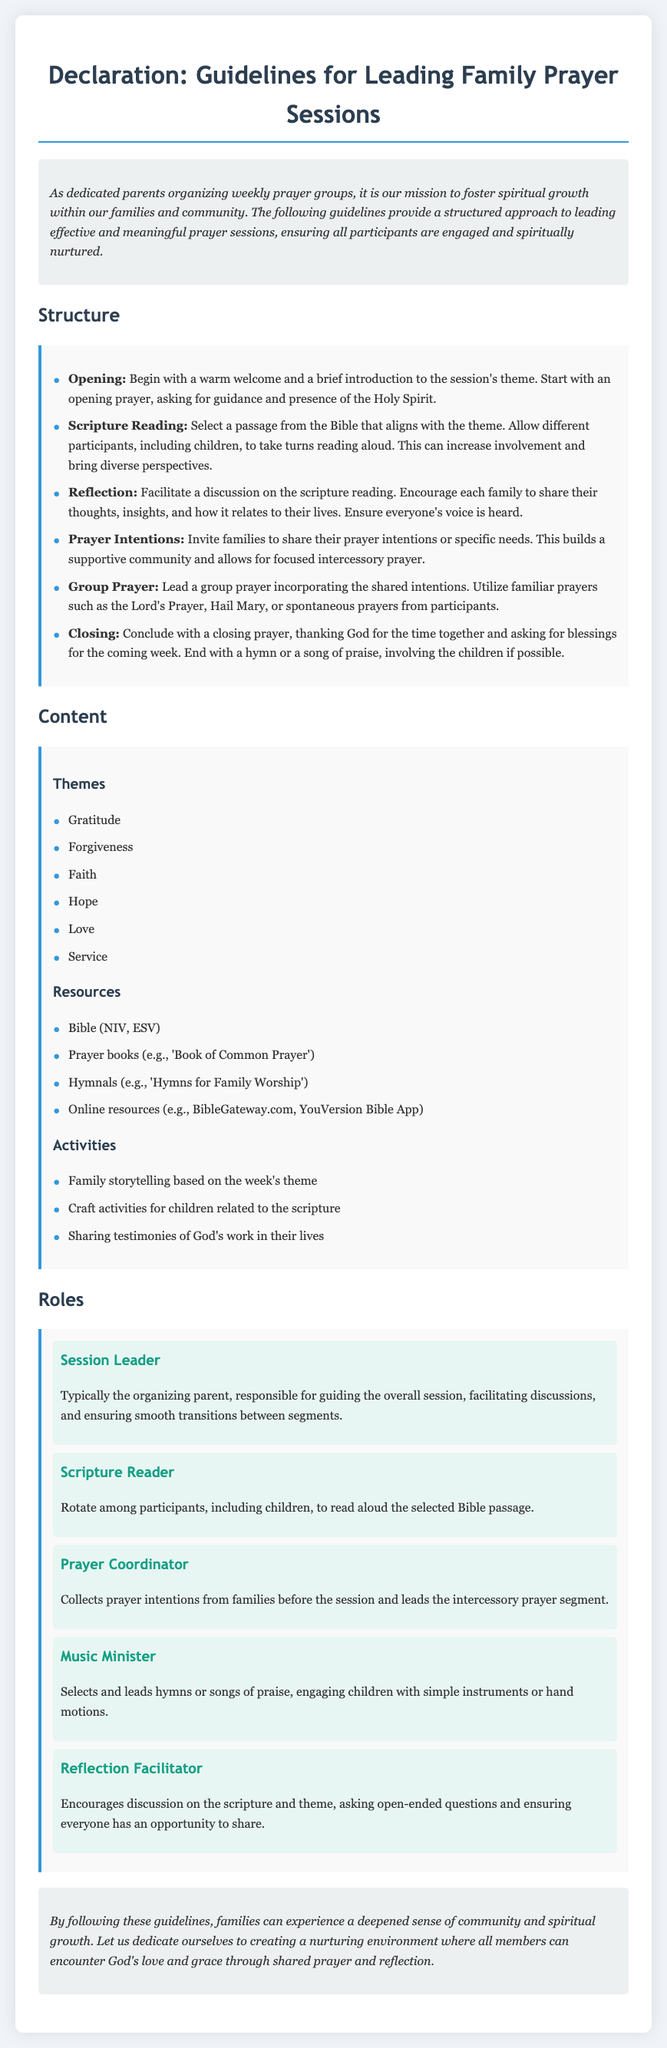what is the title of the document? The title of the document is clearly stated at the top of the content.
Answer: Declaration: Guidelines for Leading Family Prayer Sessions what are the two main sections listed under Structure? This section describes the order of the prayer session and includes specific components.
Answer: Opening and Group Prayer how many themes are suggested for the prayer sessions? The document provides a list of themes under the Content section.
Answer: Six who is typically the session leader? The document describes this role's responsibility and mentions who usually takes on this role.
Answer: The organizing parent what are the resources mentioned for prayer sessions? The Content section specifies resources to be used during the sessions.
Answer: Bible (NIV, ESV) which role is responsible for collecting prayer intentions? This role’s responsibility is outlined in the Roles section of the document.
Answer: Prayer Coordinator what is the purpose of the reflection segment? The document describes this segment's goal in the Structure section.
Answer: Encourage discussion on the scripture which themes are included in the Content section? This question pertains to the list of spiritual themes mentioned.
Answer: Gratitude, Forgiveness, Faith, Hope, Love, Service what is the background color of the guideline sections? The document visually represents these sections against a specific color backdrop.
Answer: Light gray (or #f9f9f9) 